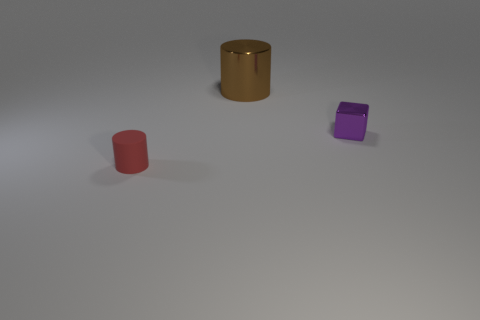Add 2 brown shiny cylinders. How many objects exist? 5 Subtract all cylinders. How many objects are left? 1 Subtract all big gray blocks. Subtract all tiny red rubber cylinders. How many objects are left? 2 Add 3 purple metallic things. How many purple metallic things are left? 4 Add 2 tiny brown shiny blocks. How many tiny brown shiny blocks exist? 2 Subtract 0 red cubes. How many objects are left? 3 